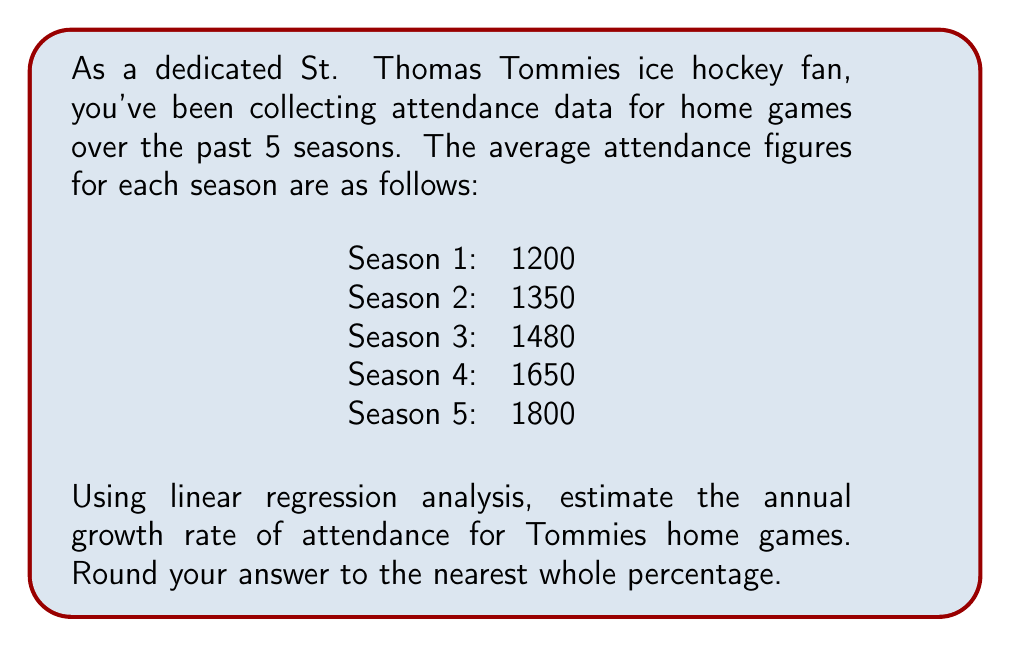Give your solution to this math problem. To estimate the annual growth rate using linear regression, we'll follow these steps:

1) First, let's set up our data points:
   x (season number): 1, 2, 3, 4, 5
   y (attendance): 1200, 1350, 1480, 1650, 1800

2) We'll use the linear regression formula:
   $$y = mx + b$$
   where m is the slope and b is the y-intercept.

3) To find m and b, we'll use these formulas:
   $$m = \frac{n\sum xy - \sum x \sum y}{n\sum x^2 - (\sum x)^2}$$
   $$b = \frac{\sum y - m\sum x}{n}$$

4) Let's calculate the necessary sums:
   $\sum x = 15$
   $\sum y = 7480$
   $\sum xy = 24910$
   $\sum x^2 = 55$
   $n = 5$

5) Now, let's plug these into our formulas:
   $$m = \frac{5(24910) - 15(7480)}{5(55) - 15^2} = \frac{124550 - 112200}{275 - 225} = \frac{12350}{50} = 247$$

   $$b = \frac{7480 - 247(15)}{5} = \frac{7480 - 3705}{5} = 755$$

6) Our regression line is therefore:
   $$y = 247x + 755$$

7) To find the growth rate, we need to compare the predicted attendance for any two consecutive seasons. Let's use seasons 1 and 2:

   Season 1: $y = 247(1) + 755 = 1002$
   Season 2: $y = 247(2) + 755 = 1249$

8) The growth rate is:
   $$\text{Growth Rate} = \frac{1249 - 1002}{1002} \approx 0.2465 \text{ or } 24.65\%$$

9) Rounding to the nearest whole percentage gives us 25%.
Answer: 25% 